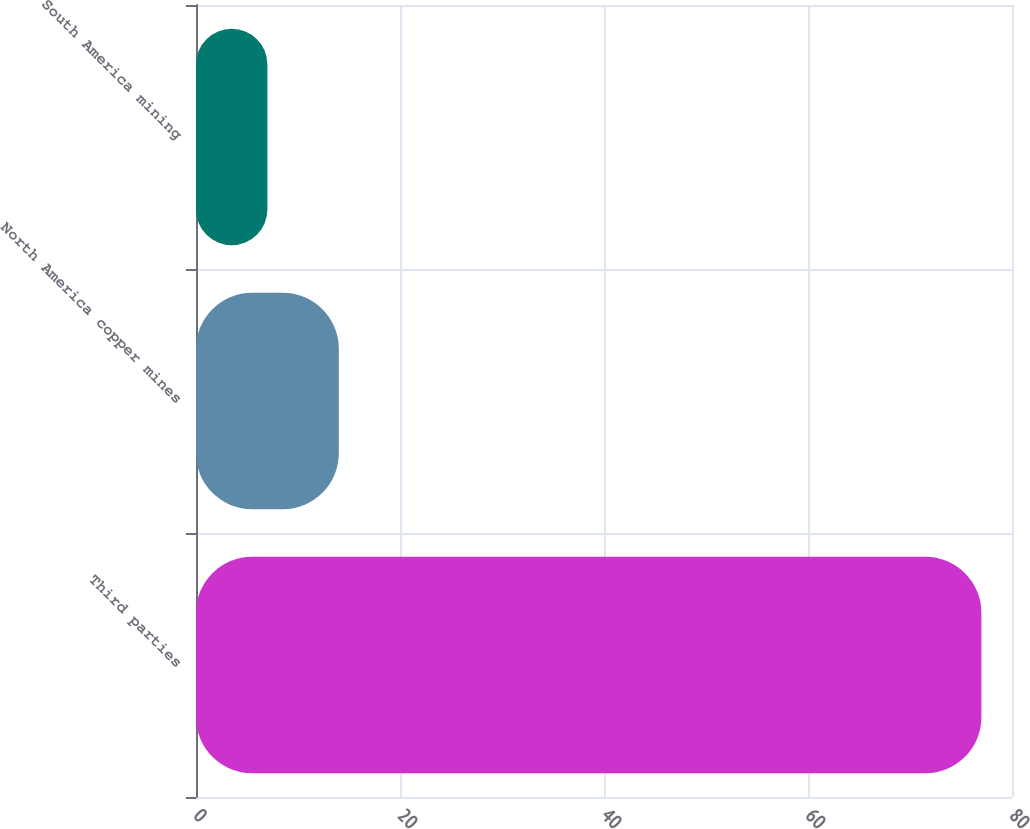Convert chart. <chart><loc_0><loc_0><loc_500><loc_500><bar_chart><fcel>Third parties<fcel>North America copper mines<fcel>South America mining<nl><fcel>77<fcel>14<fcel>7<nl></chart> 